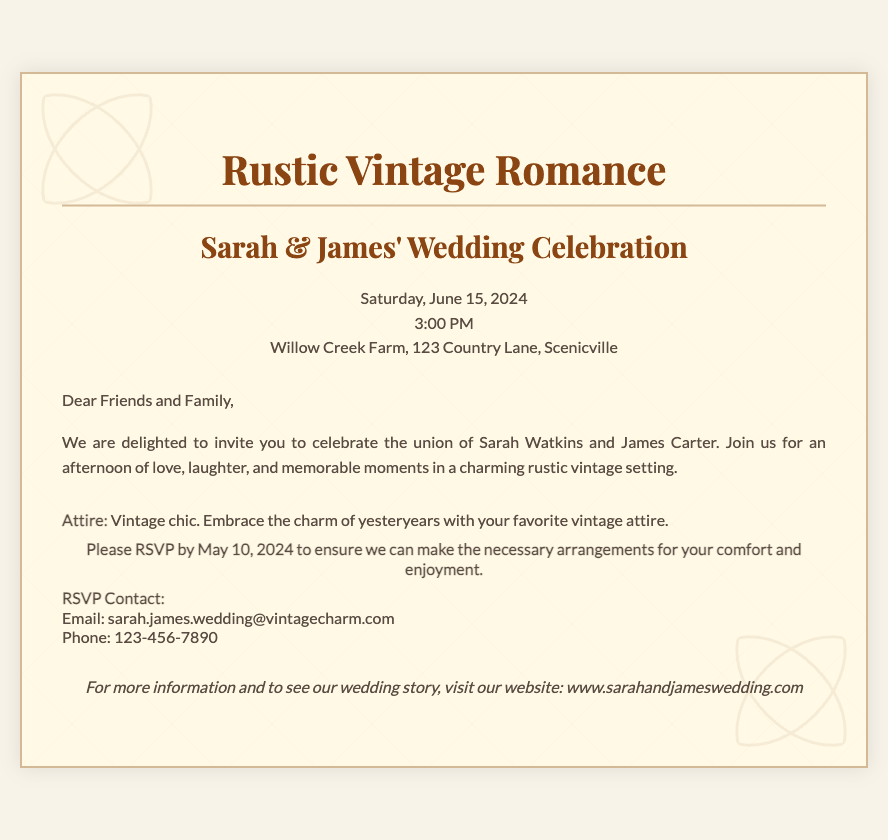What is the theme of the wedding? The theme is explicitly stated at the top of the invitation in bold text.
Answer: Rustic Vintage Romance Who are the couple getting married? The names of the couple are prominently displayed in the header section of the invitation.
Answer: Sarah & James What is the date of the wedding? The date is mentioned in the header section alongside the couple's names.
Answer: Saturday, June 15, 2024 What time does the wedding ceremony start? The time is specified right after the wedding date in the document.
Answer: 3:00 PM Where is the wedding taking place? The location is provided in the header section of the invitation.
Answer: Willow Creek Farm, 123 Country Lane, Scenicville What attire is requested for the guests? The dress code is highlighted in the details section of the document.
Answer: Vintage chic By when should guests RSVP? The RSVP deadline is clearly stated within the details section of the invitation.
Answer: May 10, 2024 What is the RSVP contact email? The email address for RSVP is mentioned in the details section of the document.
Answer: sarah.james.wedding@vintagecharm.com What is the purpose of the invitation? The introduction section outlines the primary intention of the invitation.
Answer: Celebrate the union of Sarah Watkins and James Carter 